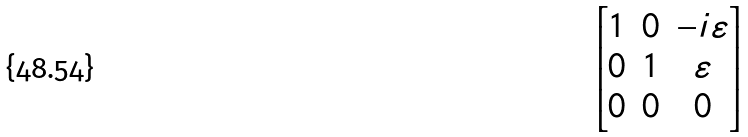Convert formula to latex. <formula><loc_0><loc_0><loc_500><loc_500>\begin{bmatrix} 1 & 0 & - i \varepsilon \\ 0 & 1 & \varepsilon \\ 0 & 0 & 0 \end{bmatrix}</formula> 